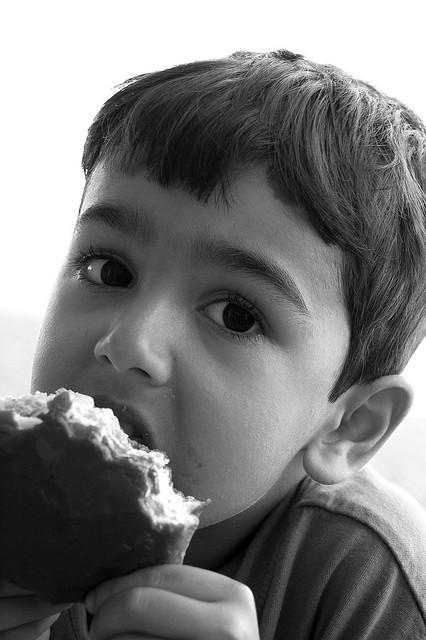What gender is the child that is eating the food?
Short answer required. Male. How old does he look?
Short answer required. 4. What is the child doing in this picture?
Concise answer only. Eating. 